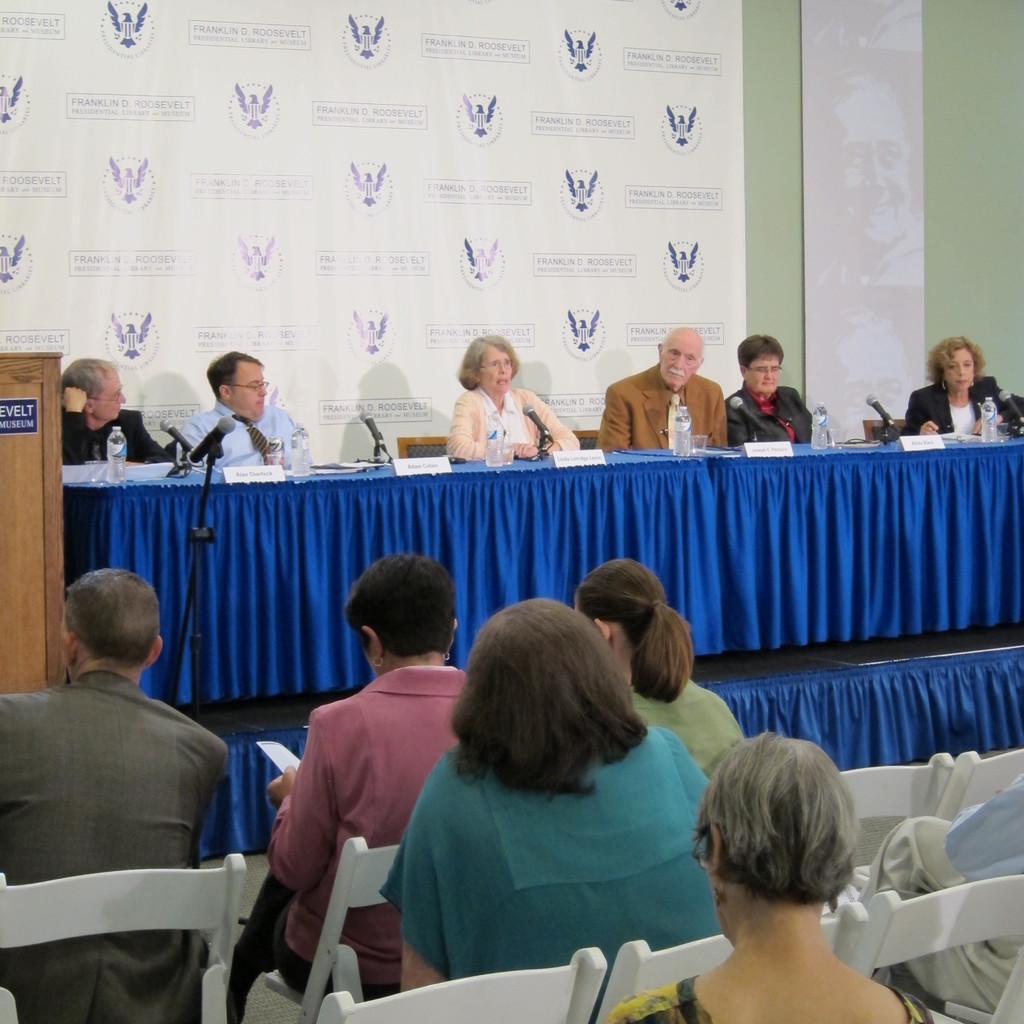In one or two sentences, can you explain what this image depicts? This picture is clicked inside a conference hall. We see six people sitting on chair on the stage and the woman in the middle is talking a microphone. On the table, we can see water bottles and microphones and also the name tags placed on it. There are 6 people sitting, sat on the chair. In the middle left corner of this picture, we see a podium. Behind that, we see a banner with some text written on it. Beside that, we see a wall which is green in color. 